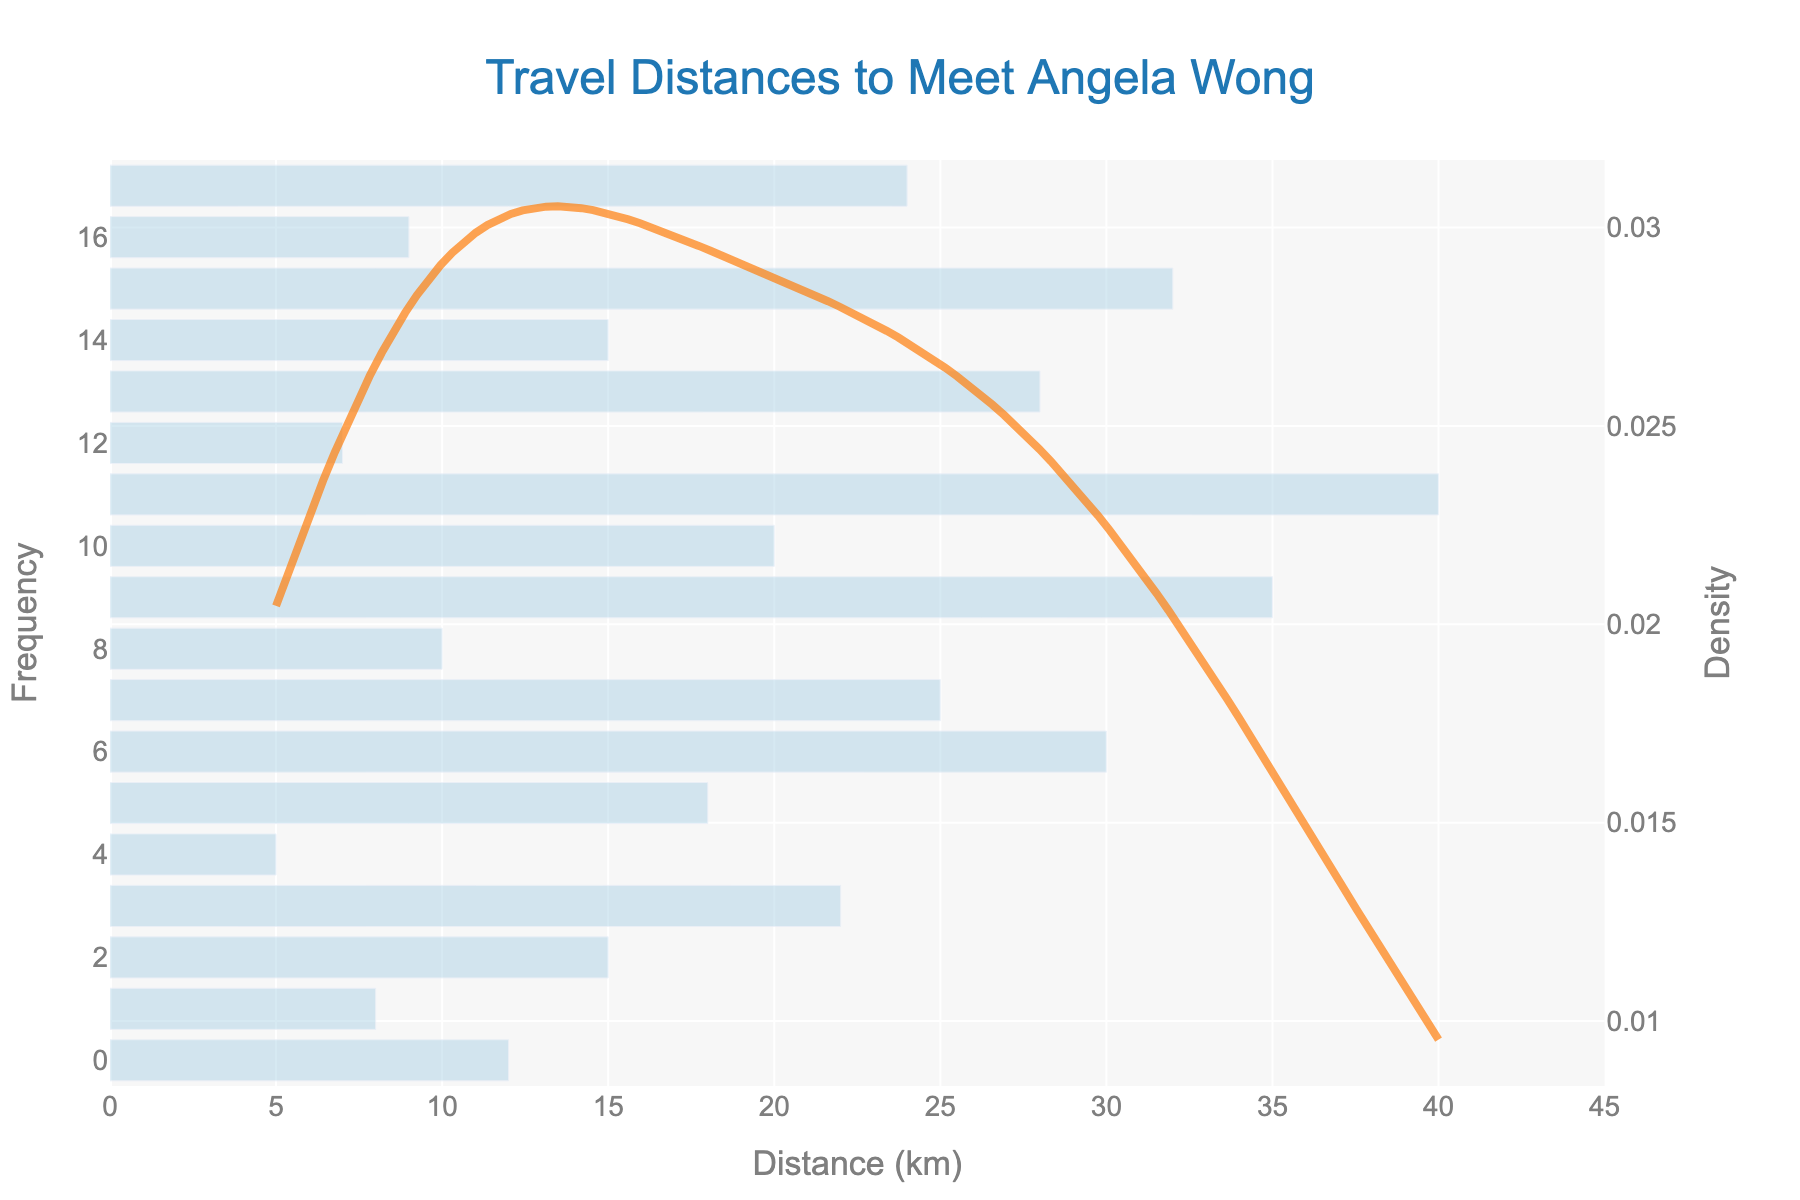what is the title of the figure? The title is located at the top of the figure and is clearly marked. It reads "Travel Distances to Meet Angela Wong".
Answer: Travel Distances to Meet Angela Wong What are the units used for the x-axis? The x-axis represents the travel distances, and the units are labeled as kilometers (km).
Answer: kilometers (km) What is the maximum travel distance recorded on the x-axis? The maximum travel distance on the x-axis can be observed by identifying the last tick mark, which is set at 40 km.
Answer: 40 km How does the height of the KDE curve compare to the bars in the histogram? The height of the KDE curve peaks higher than the majority of the bars in the histogram. This indicates a higher density of certain travel distances around a specific range.
Answer: Higher Which travel distance has the highest frequency according to the histogram? By scanning the heights of the bars in the histogram, the distance with the highest frequency appears to be at 15 km.
Answer: 15 km What does the secondary y-axis represent? The secondary y-axis on the right side represents the density, which is used for the KDE curve.
Answer: density Based on the KDE curve, at what distance is there a peak density? The peak density value in the KDE curve is located around the 15 km mark, indicating that this distance is most densely represented in the data.
Answer: around 15 km Is there a notable increase or decrease in travel distances over the years? The histogram shows travel distances increasing over time with more instances occurring at higher distances in later years. This suggests that travel distances have generally increased.
Answer: Increase How many travel distances are recorded above 30 km? Observing the histogram bars above 30 km, there are three travel distances recorded (30, 35, 40 km) indicating 3 instances.
Answer: 3 instances What can you deduce from the combination of the histogram and KDE curve about the common travel distance? The KDE curve peaks around 15 km, which corresponds with the highest bar in the histogram, indicating that travel distances around 15 km are the most common.
Answer: 15 km is the most common 